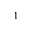<formula> <loc_0><loc_0><loc_500><loc_500>^ { 1 }</formula> 